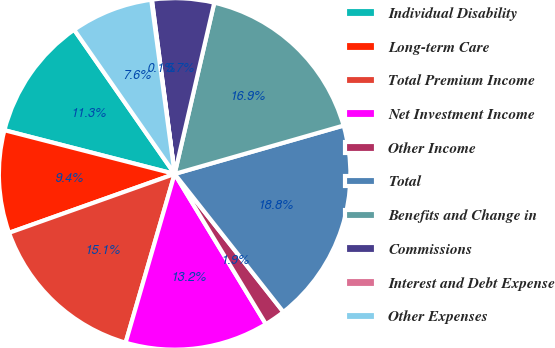Convert chart. <chart><loc_0><loc_0><loc_500><loc_500><pie_chart><fcel>Individual Disability<fcel>Long-term Care<fcel>Total Premium Income<fcel>Net Investment Income<fcel>Other Income<fcel>Total<fcel>Benefits and Change in<fcel>Commissions<fcel>Interest and Debt Expense<fcel>Other Expenses<nl><fcel>11.31%<fcel>9.44%<fcel>15.06%<fcel>13.19%<fcel>1.93%<fcel>18.82%<fcel>16.94%<fcel>5.69%<fcel>0.06%<fcel>7.56%<nl></chart> 